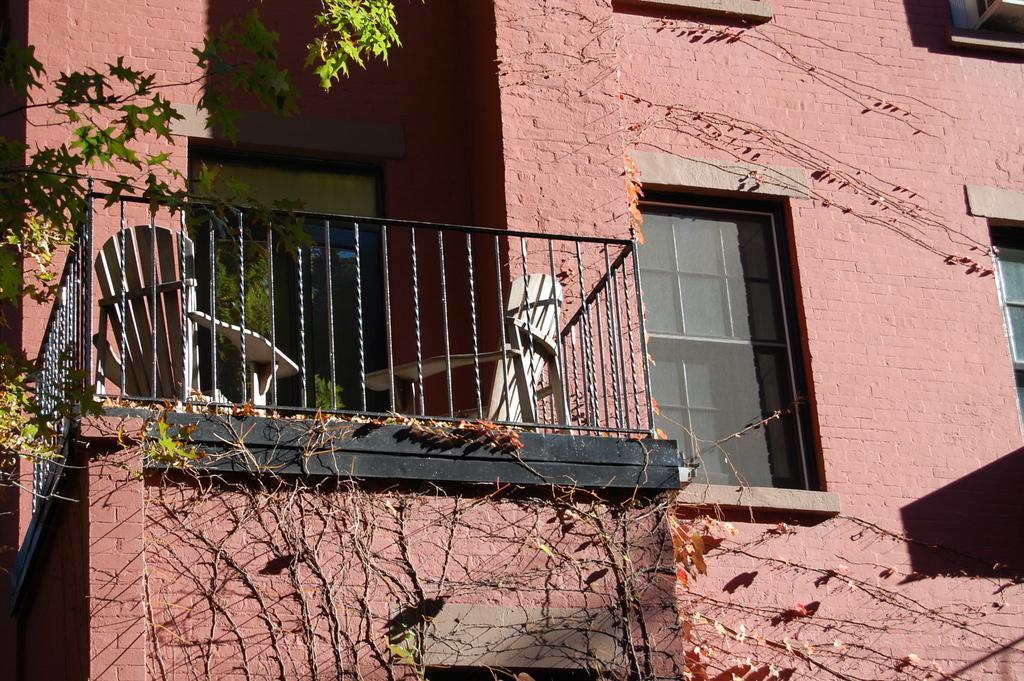Describe this image in one or two sentences. In this image there is a wall of the building. There are glass windows to the walls. In the center there is a railing. Beside the railing there are chairs. In the background there is a door to the building. There are leaves and stems on the buildings. 